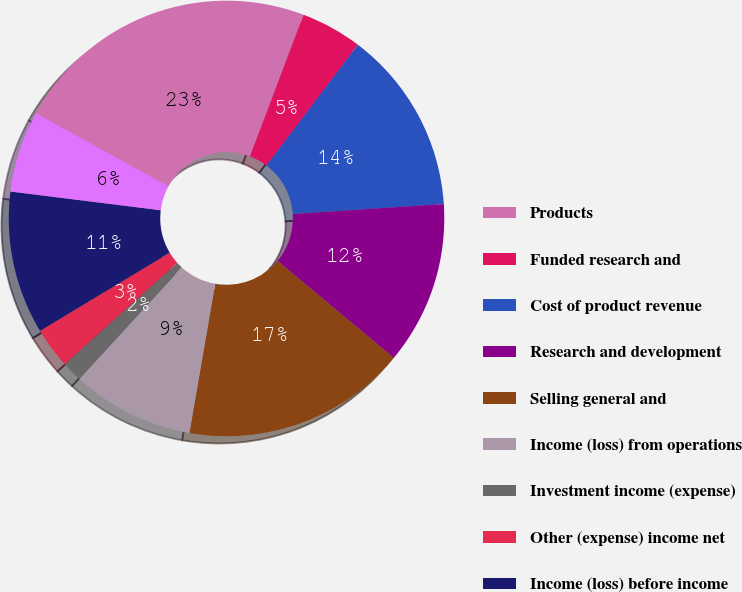Convert chart. <chart><loc_0><loc_0><loc_500><loc_500><pie_chart><fcel>Products<fcel>Funded research and<fcel>Cost of product revenue<fcel>Research and development<fcel>Selling general and<fcel>Income (loss) from operations<fcel>Investment income (expense)<fcel>Other (expense) income net<fcel>Income (loss) before income<fcel>Income tax (benefit)<nl><fcel>22.73%<fcel>4.55%<fcel>13.64%<fcel>12.12%<fcel>16.67%<fcel>9.09%<fcel>1.52%<fcel>3.03%<fcel>10.61%<fcel>6.06%<nl></chart> 